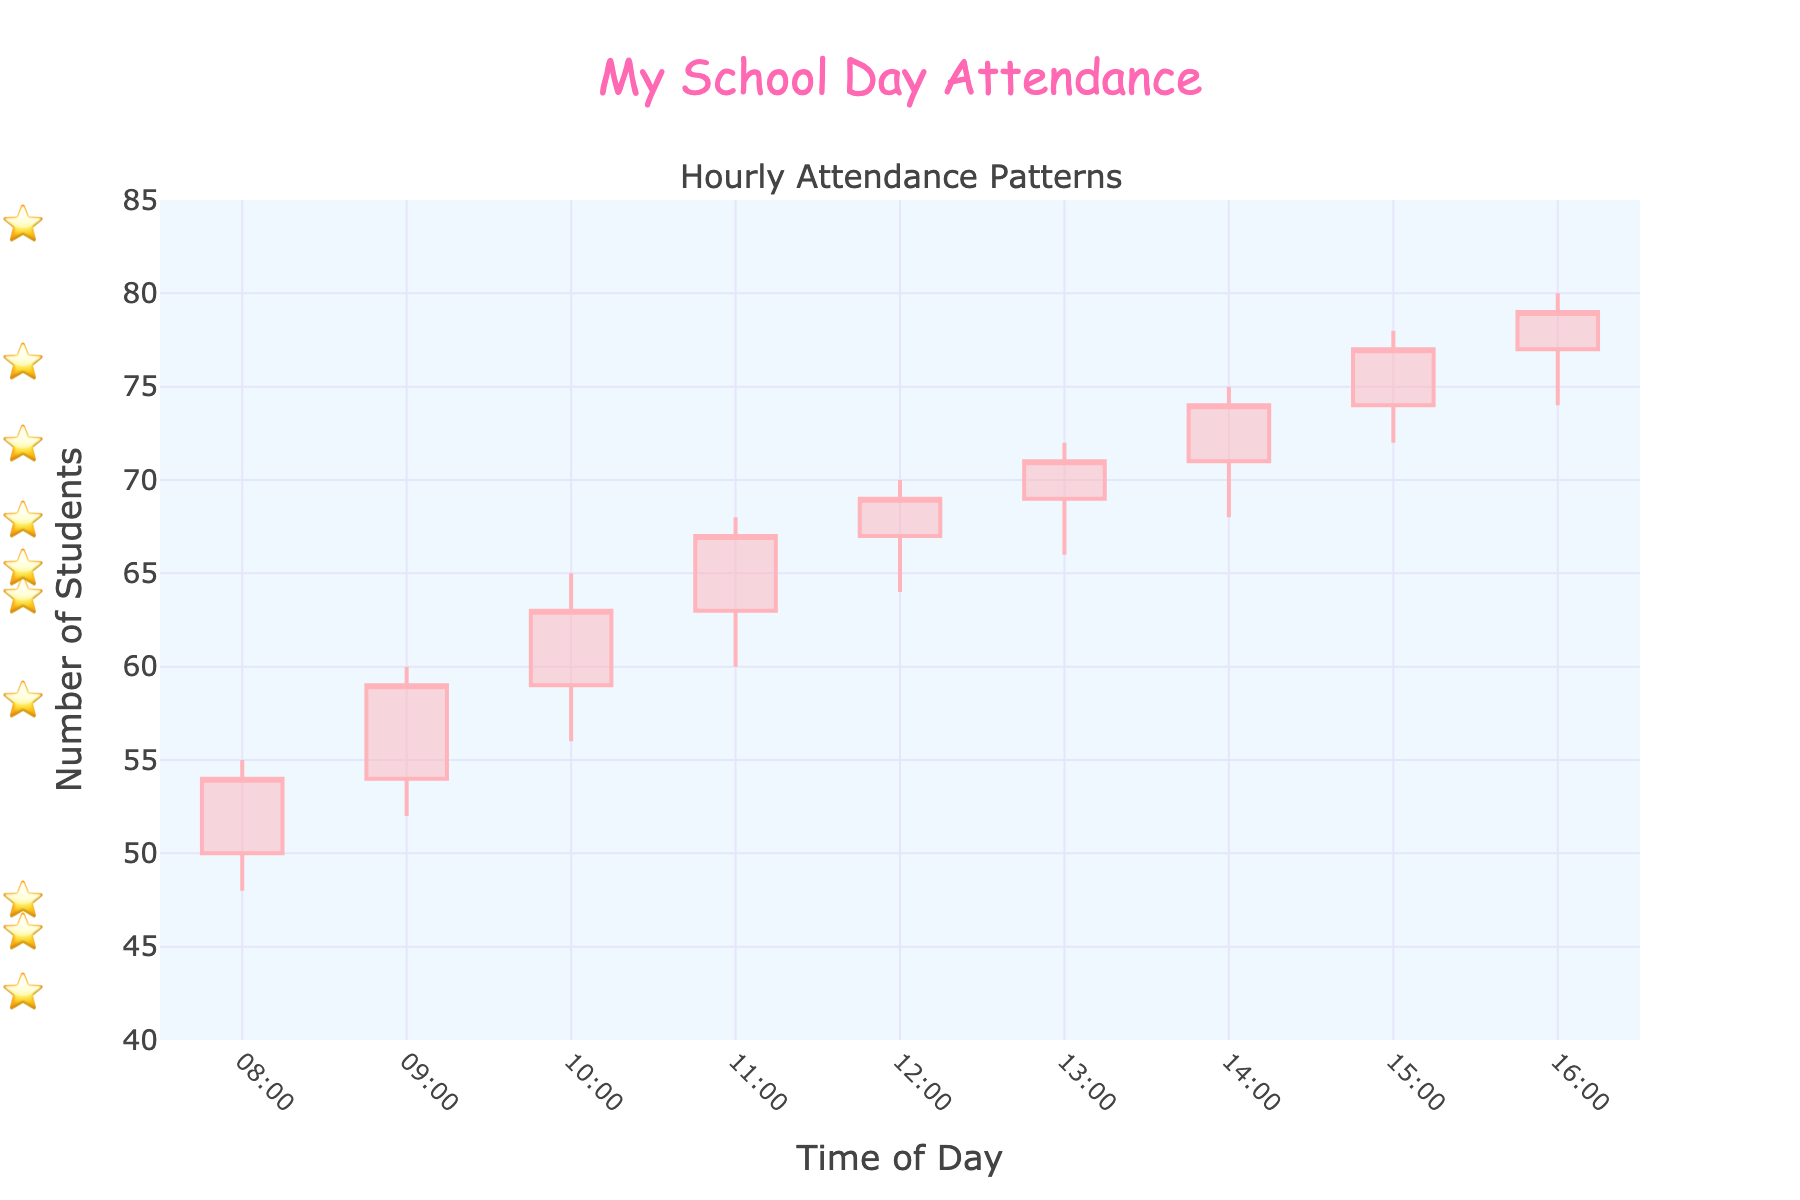what is the title of the plot? The title of the plot is prominently displayed at the top of the figure within the layout configuration, indicating the focus of the chart.
Answer: My School Day Attendance how many time slots are displayed on the x-axis? You can count each individual time slot displayed on the x-axis based on the date and hour provided in the data, ranging from the start to the end time.
Answer: 9 During which time slot did the number of students reach the highest peak within the hour? By examining the high price for each candlestick data point on the y-axis, you can identify the highest peak value and its corresponding time.
Answer: 2023-10-02_14:00 (75 students) Which color represents an increase in attendance? By looking at the visual design of the candlestick plot, the increasing number of students is visually indicated by one specific color used to render the candlesticks.
Answer: Light pink represents an increase in attendance What was the attendance difference between the opening and closing of 2023-10-02_15:00? Find the values for opening and closing from the data provided for this specific time slot and calculate the difference between them using subtraction.
Answer: 3 How does the attendance at 10:00 compare to that at 16:00? Compare the closing values for the two specific times given in the data. Attendance at 16:00 is 79, while at 10:00 it is 63, so decide which is greater or lesser.
Answer: 16:00 has higher attendance than 10:00 what is the average high attendance value across all time slots? Add the high values for each time slot and divide by the total number of time slots to find the average. The sum is 553 and the number of slots is 9, so 553/9.
Answer: Approximately 61.44 During which hour did attendance not change compared to the previous hour? Look for the time slot where the difference between the closing value of the previous hour and the closing value of the current hour is zero. You will notice there is no such hour in the data provided.
Answer: None If you look at the candlestick data, how do the attendance highs at 08:00 and 12:00 compare? Identify the high attendance numbers from the data for the specified times and compare them. For 08:00 it’s 55 and for 12:00 it’s 70.
Answer: 12:00 is higher than 08:00 During which hour did the lowest attendance occur within its time slot? Look at the low attendance values for each hour and identify the minimum among them. On 2023-10-02_08:00 the low value is 48, which is the lowest.
Answer: 08:00 